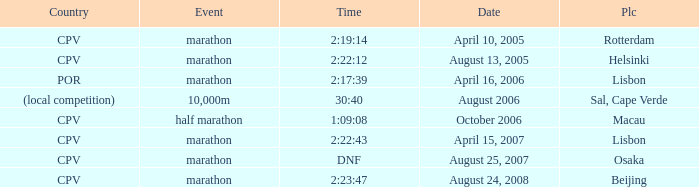What is the Place of the half marathon Event? Macau. 